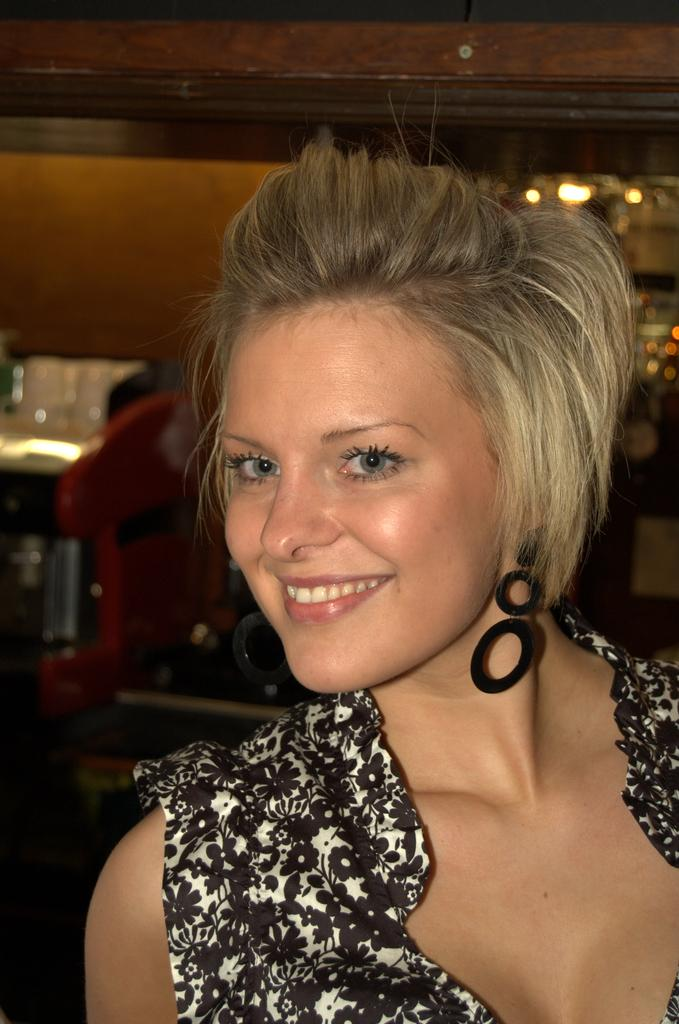Who is present in the image? There is a woman in the image. What is the woman doing in the image? The woman is smiling in the image. What is the woman wearing in the image? The woman is wearing a black and white dress in the image. What type of plough is the woman using in the image? There is no plough present in the image; it features a woman wearing a black and white dress and smiling. 